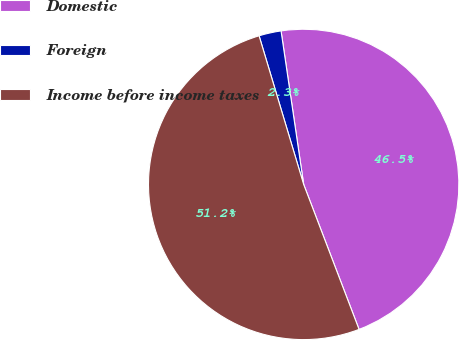Convert chart. <chart><loc_0><loc_0><loc_500><loc_500><pie_chart><fcel>Domestic<fcel>Foreign<fcel>Income before income taxes<nl><fcel>46.52%<fcel>2.31%<fcel>51.17%<nl></chart> 